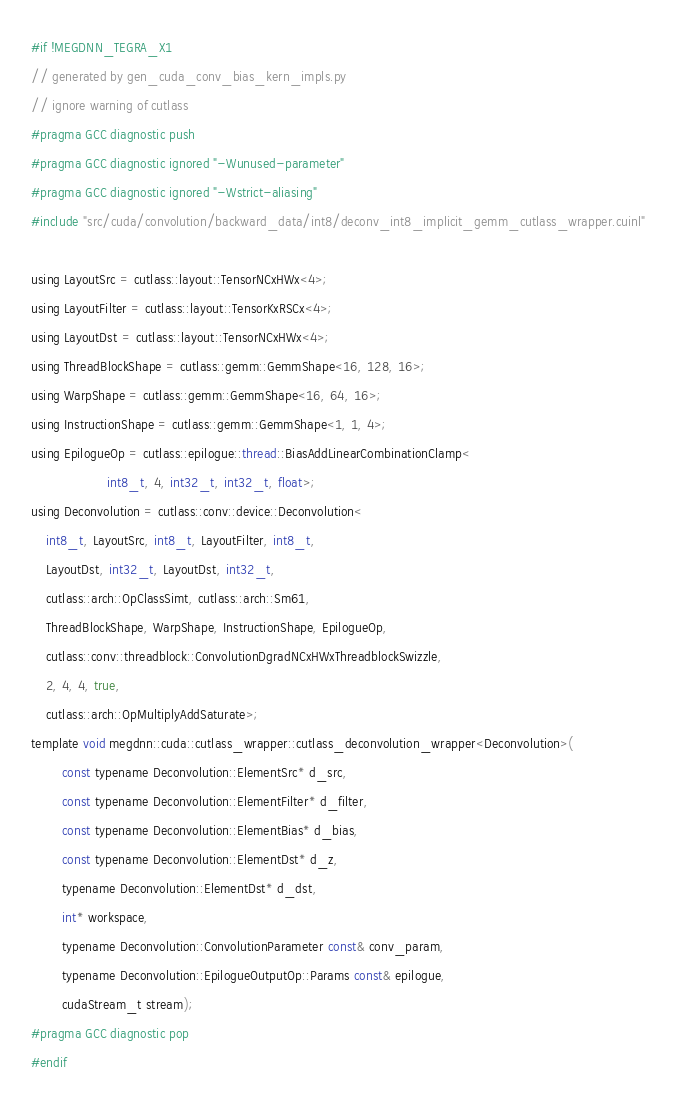Convert code to text. <code><loc_0><loc_0><loc_500><loc_500><_Cuda_>#if !MEGDNN_TEGRA_X1
// generated by gen_cuda_conv_bias_kern_impls.py
// ignore warning of cutlass
#pragma GCC diagnostic push
#pragma GCC diagnostic ignored "-Wunused-parameter"
#pragma GCC diagnostic ignored "-Wstrict-aliasing"
#include "src/cuda/convolution/backward_data/int8/deconv_int8_implicit_gemm_cutlass_wrapper.cuinl"

using LayoutSrc = cutlass::layout::TensorNCxHWx<4>;
using LayoutFilter = cutlass::layout::TensorKxRSCx<4>;
using LayoutDst = cutlass::layout::TensorNCxHWx<4>;
using ThreadBlockShape = cutlass::gemm::GemmShape<16, 128, 16>;
using WarpShape = cutlass::gemm::GemmShape<16, 64, 16>;
using InstructionShape = cutlass::gemm::GemmShape<1, 1, 4>;
using EpilogueOp = cutlass::epilogue::thread::BiasAddLinearCombinationClamp<
                    int8_t, 4, int32_t, int32_t, float>;
using Deconvolution = cutlass::conv::device::Deconvolution<
    int8_t, LayoutSrc, int8_t, LayoutFilter, int8_t, 
    LayoutDst, int32_t, LayoutDst, int32_t, 
    cutlass::arch::OpClassSimt, cutlass::arch::Sm61, 
    ThreadBlockShape, WarpShape, InstructionShape, EpilogueOp, 
    cutlass::conv::threadblock::ConvolutionDgradNCxHWxThreadblockSwizzle, 
    2, 4, 4, true, 
    cutlass::arch::OpMultiplyAddSaturate>;
template void megdnn::cuda::cutlass_wrapper::cutlass_deconvolution_wrapper<Deconvolution>(
        const typename Deconvolution::ElementSrc* d_src, 
        const typename Deconvolution::ElementFilter* d_filter, 
        const typename Deconvolution::ElementBias* d_bias, 
        const typename Deconvolution::ElementDst* d_z, 
        typename Deconvolution::ElementDst* d_dst, 
        int* workspace, 
        typename Deconvolution::ConvolutionParameter const& conv_param, 
        typename Deconvolution::EpilogueOutputOp::Params const& epilogue, 
        cudaStream_t stream);
#pragma GCC diagnostic pop
#endif
</code> 